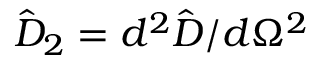Convert formula to latex. <formula><loc_0><loc_0><loc_500><loc_500>\hat { D } _ { 2 } = d ^ { 2 } \hat { D } / d \Omega ^ { 2 }</formula> 